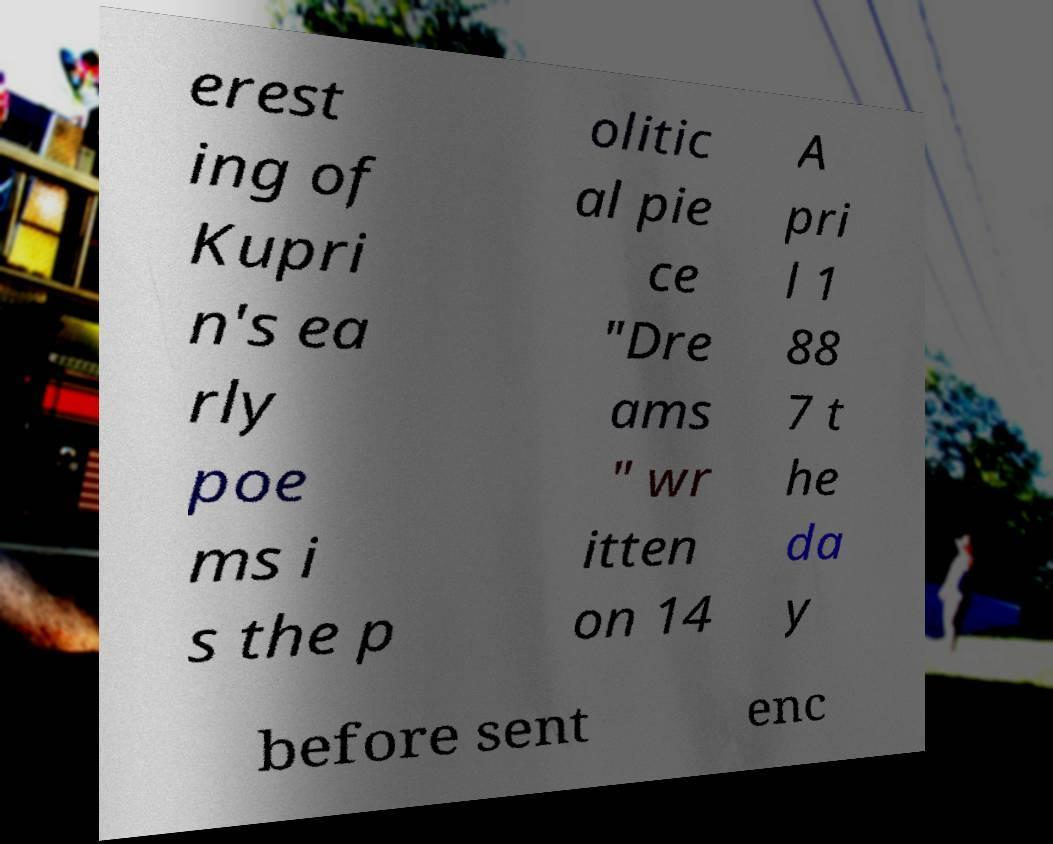Please identify and transcribe the text found in this image. erest ing of Kupri n's ea rly poe ms i s the p olitic al pie ce "Dre ams " wr itten on 14 A pri l 1 88 7 t he da y before sent enc 